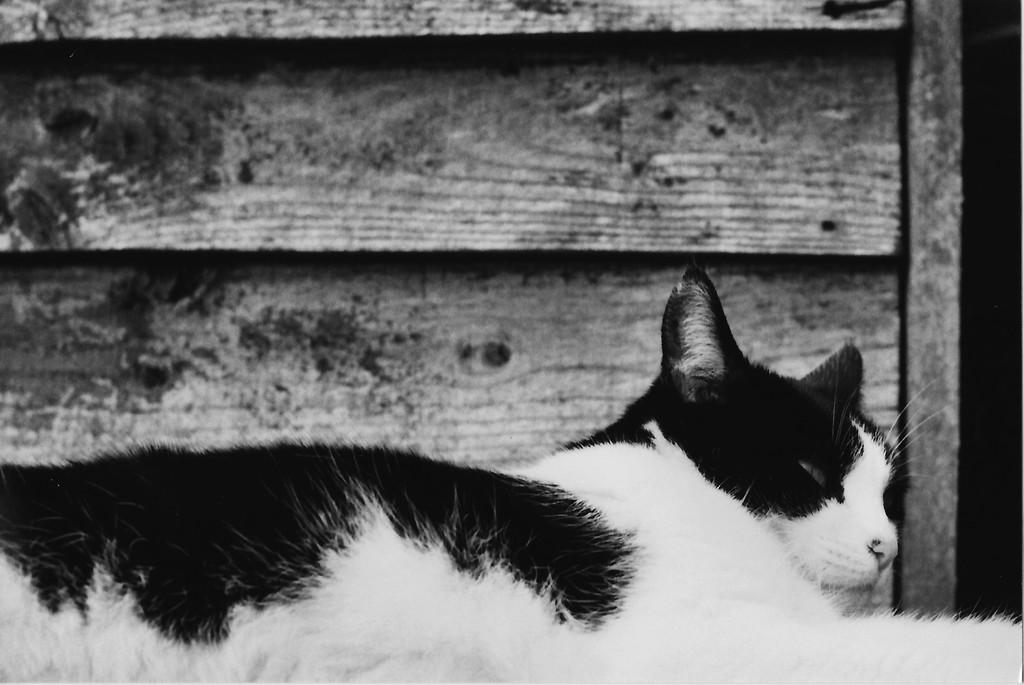What type of animal is in the image? There is a cat in the image. Where is the cat located in the image? The cat is at the bottom side of the image. What type of material is used for the wall in the image? There is a wooden wall in the image. What is the title of the song playing in the background of the image? There is no song or background music present in the image, so it is not possible to determine the title of a song. 